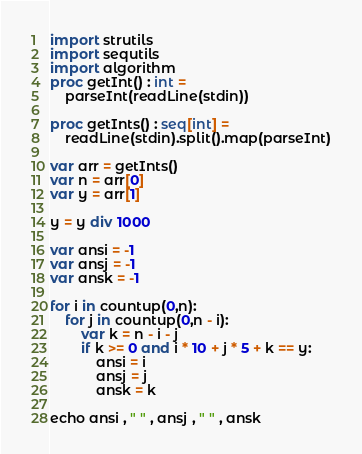<code> <loc_0><loc_0><loc_500><loc_500><_Nim_>import strutils
import sequtils
import algorithm
proc getInt() : int =
    parseInt(readLine(stdin))

proc getInts() : seq[int] = 
    readLine(stdin).split().map(parseInt)

var arr = getInts()
var n = arr[0]
var y = arr[1]

y = y div 1000

var ansi = -1
var ansj = -1
var ansk = -1

for i in countup(0,n):
    for j in countup(0,n - i):
        var k = n - i - j
        if k >= 0 and i * 10 + j * 5 + k == y:
            ansi = i
            ansj = j
            ansk = k

echo ansi , " " , ansj , " " , ansk</code> 